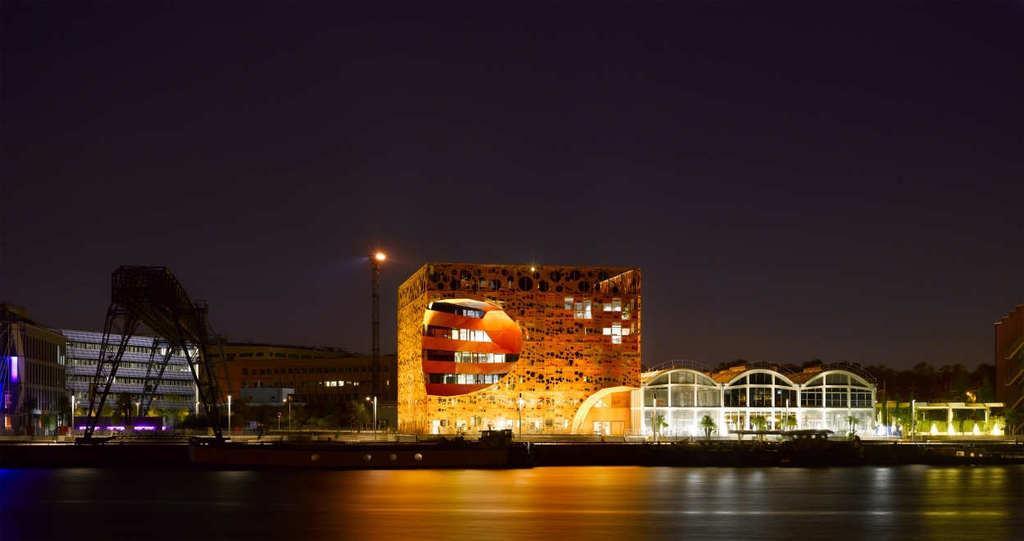Can you describe this image briefly? In this image, we can see buildings, trees, lights, poles, an architecture, benches and we can see a fence. At the bottom, there is a floor and at the top, there is sky. 